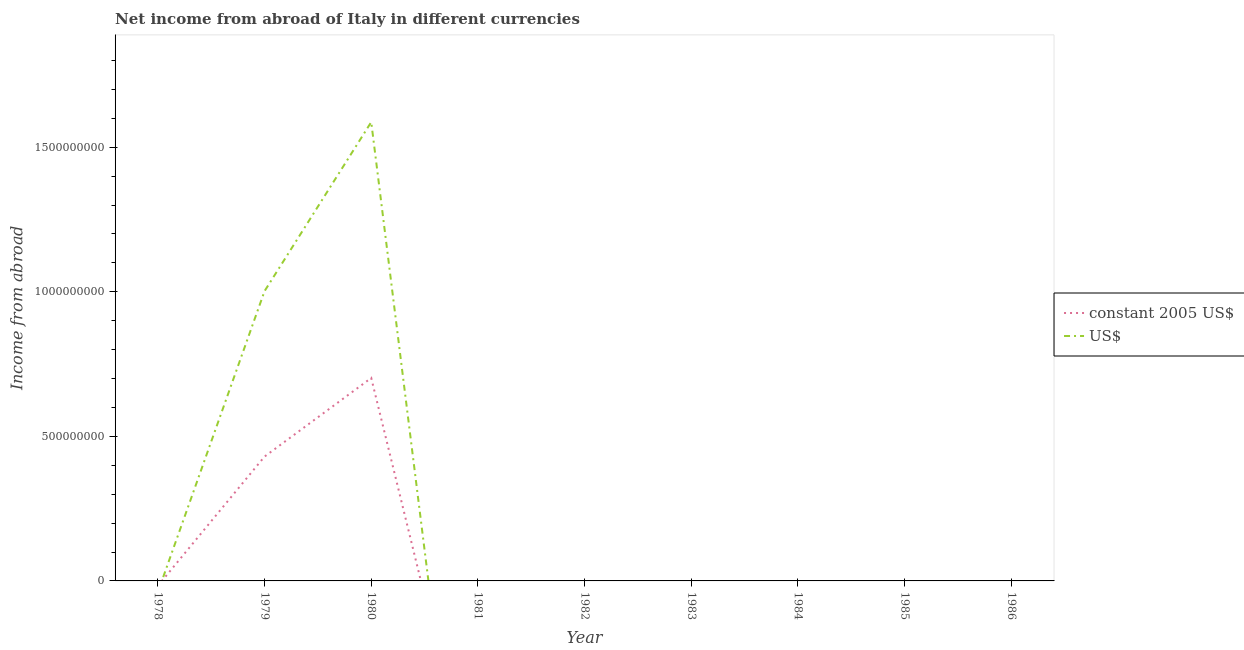What is the income from abroad in constant 2005 us$ in 1985?
Keep it short and to the point. 0. Across all years, what is the maximum income from abroad in constant 2005 us$?
Your answer should be compact. 7.02e+08. Across all years, what is the minimum income from abroad in constant 2005 us$?
Keep it short and to the point. 0. In which year was the income from abroad in constant 2005 us$ maximum?
Your answer should be very brief. 1980. What is the total income from abroad in constant 2005 us$ in the graph?
Offer a terse response. 1.13e+09. What is the difference between the income from abroad in constant 2005 us$ in 1978 and the income from abroad in us$ in 1982?
Provide a succinct answer. 0. What is the average income from abroad in us$ per year?
Provide a short and direct response. 2.88e+08. What is the difference between the highest and the lowest income from abroad in constant 2005 us$?
Ensure brevity in your answer.  7.02e+08. In how many years, is the income from abroad in constant 2005 us$ greater than the average income from abroad in constant 2005 us$ taken over all years?
Your answer should be compact. 2. Does the income from abroad in us$ monotonically increase over the years?
Provide a succinct answer. No. Is the income from abroad in constant 2005 us$ strictly greater than the income from abroad in us$ over the years?
Provide a short and direct response. No. Is the income from abroad in constant 2005 us$ strictly less than the income from abroad in us$ over the years?
Provide a short and direct response. No. How many years are there in the graph?
Provide a succinct answer. 9. What is the difference between two consecutive major ticks on the Y-axis?
Keep it short and to the point. 5.00e+08. Does the graph contain any zero values?
Your response must be concise. Yes. Does the graph contain grids?
Your answer should be very brief. No. How are the legend labels stacked?
Make the answer very short. Vertical. What is the title of the graph?
Your answer should be very brief. Net income from abroad of Italy in different currencies. What is the label or title of the X-axis?
Your response must be concise. Year. What is the label or title of the Y-axis?
Offer a very short reply. Income from abroad. What is the Income from abroad of constant 2005 US$ in 1978?
Provide a succinct answer. 0. What is the Income from abroad in US$ in 1978?
Offer a terse response. 0. What is the Income from abroad of constant 2005 US$ in 1979?
Offer a terse response. 4.30e+08. What is the Income from abroad in US$ in 1979?
Keep it short and to the point. 1.00e+09. What is the Income from abroad in constant 2005 US$ in 1980?
Your answer should be very brief. 7.02e+08. What is the Income from abroad in US$ in 1980?
Your response must be concise. 1.59e+09. What is the Income from abroad of constant 2005 US$ in 1981?
Your response must be concise. 0. What is the Income from abroad in US$ in 1981?
Provide a succinct answer. 0. What is the Income from abroad in US$ in 1982?
Provide a short and direct response. 0. What is the Income from abroad of constant 2005 US$ in 1983?
Make the answer very short. 0. What is the Income from abroad in US$ in 1983?
Offer a very short reply. 0. What is the Income from abroad in constant 2005 US$ in 1984?
Your response must be concise. 0. What is the Income from abroad of US$ in 1984?
Ensure brevity in your answer.  0. What is the Income from abroad in constant 2005 US$ in 1986?
Your answer should be compact. 0. Across all years, what is the maximum Income from abroad in constant 2005 US$?
Your answer should be compact. 7.02e+08. Across all years, what is the maximum Income from abroad in US$?
Offer a very short reply. 1.59e+09. What is the total Income from abroad of constant 2005 US$ in the graph?
Provide a short and direct response. 1.13e+09. What is the total Income from abroad in US$ in the graph?
Ensure brevity in your answer.  2.59e+09. What is the difference between the Income from abroad in constant 2005 US$ in 1979 and that in 1980?
Offer a terse response. -2.72e+08. What is the difference between the Income from abroad of US$ in 1979 and that in 1980?
Make the answer very short. -5.85e+08. What is the difference between the Income from abroad of constant 2005 US$ in 1979 and the Income from abroad of US$ in 1980?
Offer a terse response. -1.16e+09. What is the average Income from abroad in constant 2005 US$ per year?
Give a very brief answer. 1.26e+08. What is the average Income from abroad of US$ per year?
Your answer should be compact. 2.88e+08. In the year 1979, what is the difference between the Income from abroad of constant 2005 US$ and Income from abroad of US$?
Keep it short and to the point. -5.72e+08. In the year 1980, what is the difference between the Income from abroad of constant 2005 US$ and Income from abroad of US$?
Offer a very short reply. -8.85e+08. What is the ratio of the Income from abroad of constant 2005 US$ in 1979 to that in 1980?
Provide a short and direct response. 0.61. What is the ratio of the Income from abroad in US$ in 1979 to that in 1980?
Provide a succinct answer. 0.63. What is the difference between the highest and the lowest Income from abroad in constant 2005 US$?
Ensure brevity in your answer.  7.02e+08. What is the difference between the highest and the lowest Income from abroad in US$?
Offer a terse response. 1.59e+09. 